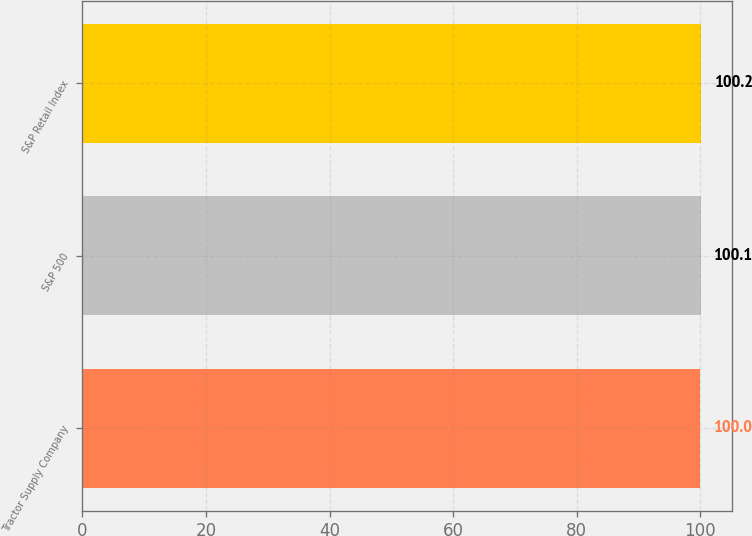Convert chart. <chart><loc_0><loc_0><loc_500><loc_500><bar_chart><fcel>Tractor Supply Company<fcel>S&P 500<fcel>S&P Retail Index<nl><fcel>100<fcel>100.1<fcel>100.2<nl></chart> 